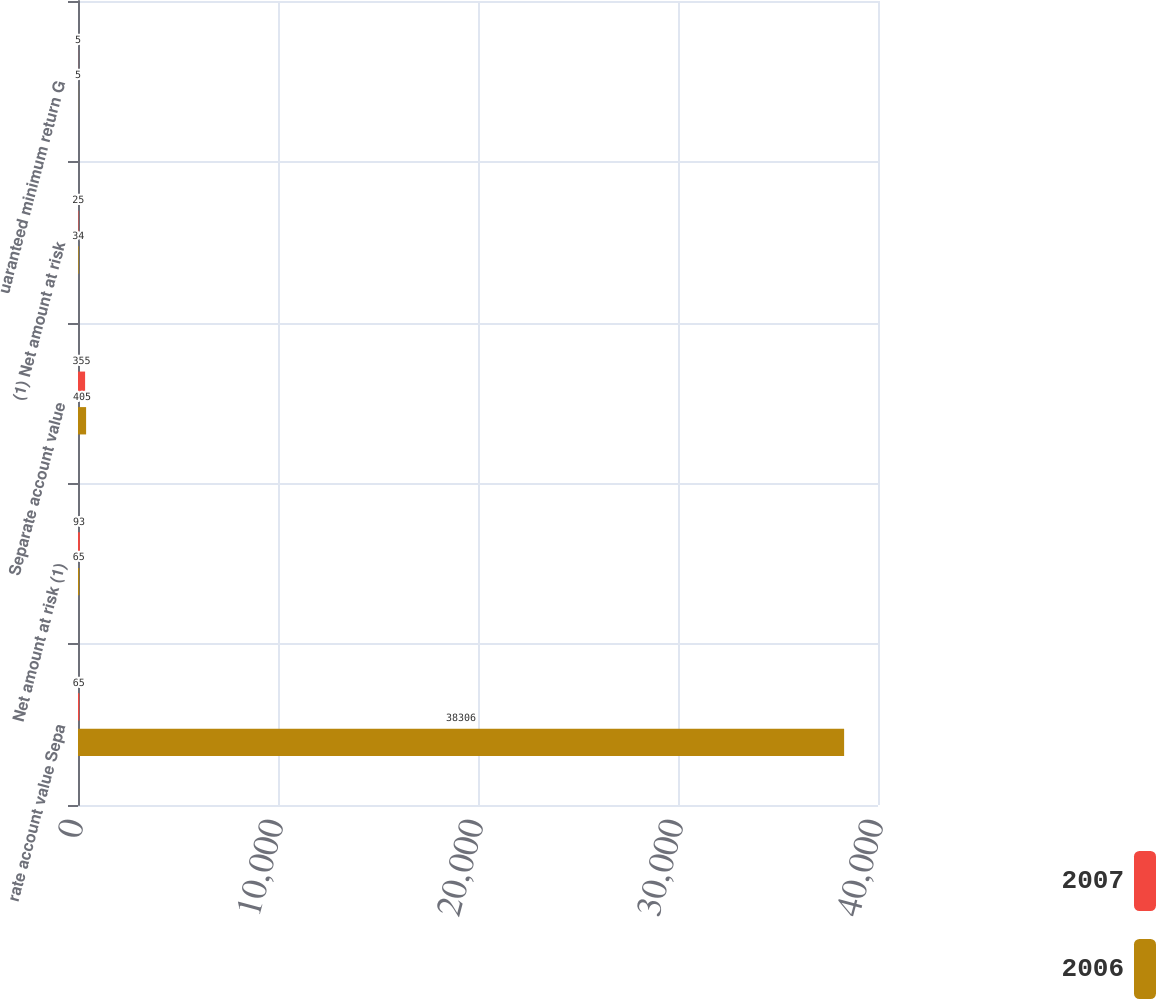<chart> <loc_0><loc_0><loc_500><loc_500><stacked_bar_chart><ecel><fcel>rate account value Sepa<fcel>Net amount at risk (1)<fcel>Separate account value<fcel>(1) Net amount at risk<fcel>uaranteed minimum return G<nl><fcel>2007<fcel>65<fcel>93<fcel>355<fcel>25<fcel>5<nl><fcel>2006<fcel>38306<fcel>65<fcel>405<fcel>34<fcel>5<nl></chart> 